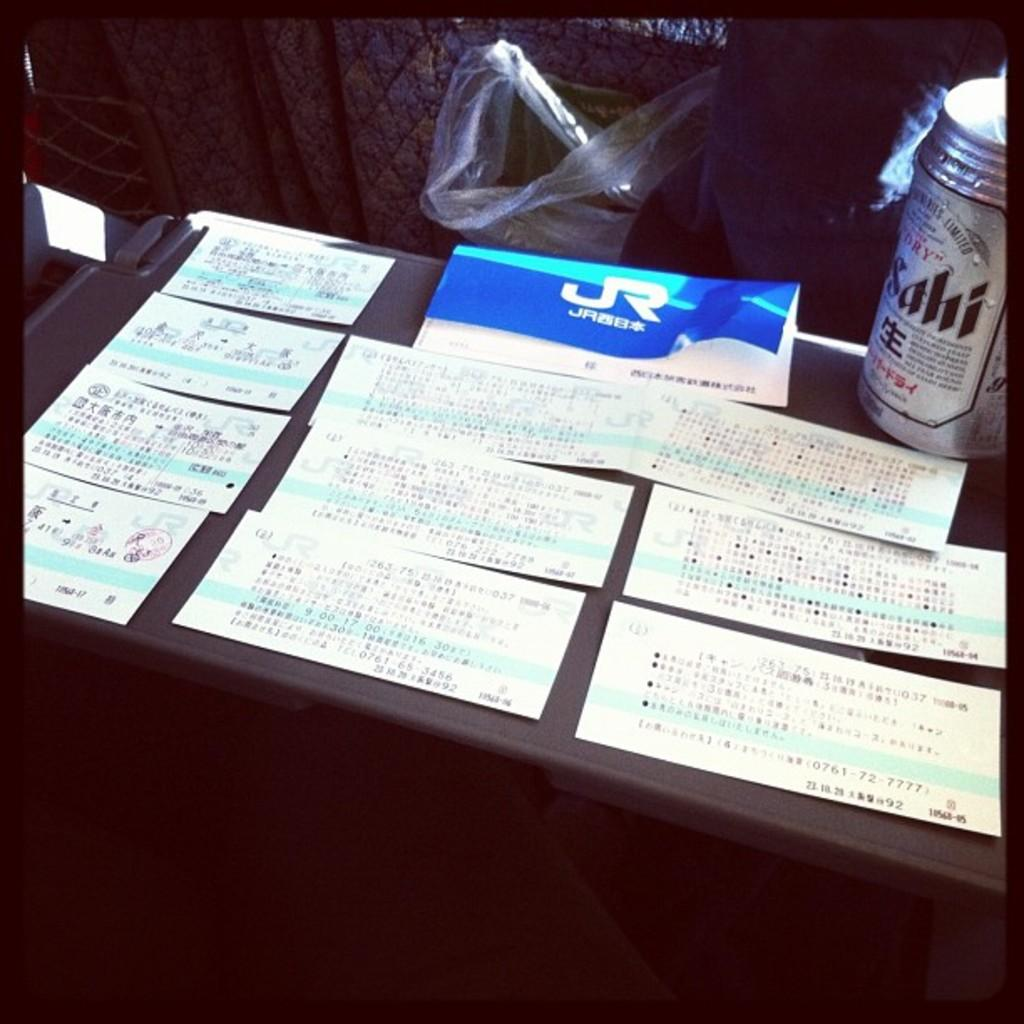<image>
Summarize the visual content of the image. Some pieces of paper on a table with a can of something called Sahi. 